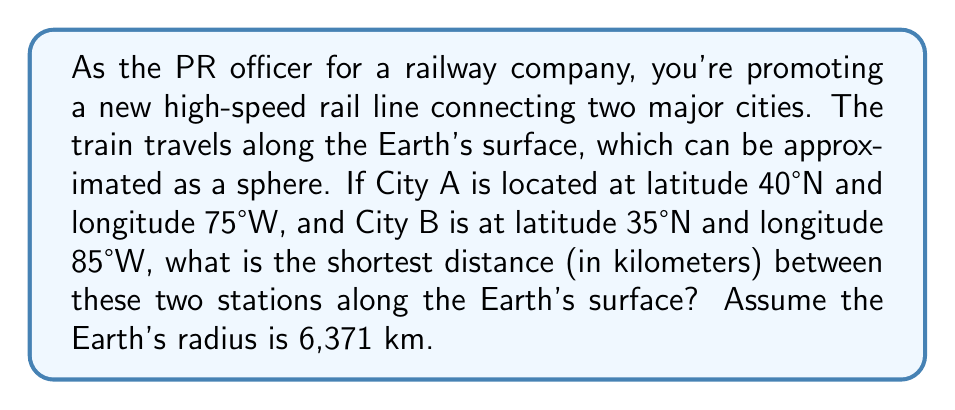Can you answer this question? To solve this problem, we'll use the Haversine formula to calculate the great-circle distance between two points on a sphere. This represents the geodesic distance between the two stations.

Step 1: Convert latitudes and longitudes to radians.
$$\begin{align*}
\phi_1 &= 40° \cdot \frac{\pi}{180} \approx 0.6981 \text{ rad} \\
\lambda_1 &= -75° \cdot \frac{\pi}{180} \approx -1.3090 \text{ rad} \\
\phi_2 &= 35° \cdot \frac{\pi}{180} \approx 0.6109 \text{ rad} \\
\lambda_2 &= -85° \cdot \frac{\pi}{180} \approx -1.4835 \text{ rad}
\end{align*}$$

Step 2: Calculate the differences in latitude and longitude.
$$\begin{align*}
\Delta\phi &= \phi_2 - \phi_1 \approx -0.0872 \text{ rad} \\
\Delta\lambda &= \lambda_2 - \lambda_1 \approx -0.1745 \text{ rad}
\end{align*}$$

Step 3: Apply the Haversine formula.
$$a = \sin^2(\frac{\Delta\phi}{2}) + \cos(\phi_1) \cos(\phi_2) \sin^2(\frac{\Delta\lambda}{2})$$

$$\begin{align*}
a &= \sin^2(-0.0436) + \cos(0.6981) \cos(0.6109) \sin^2(-0.0873) \\
&\approx 0.0019 + 0.7660 \cdot 0.8193 \cdot 0.0076 \\
&\approx 0.0019 + 0.0048 \\
&\approx 0.0067
\end{align*}$$

Step 4: Calculate the central angle.
$$c = 2 \arctan2(\sqrt{a}, \sqrt{1-a}) \approx 0.1635 \text{ rad}$$

Step 5: Calculate the great-circle distance.
$$d = R \cdot c$$
Where $R$ is the Earth's radius (6,371 km).

$$d = 6371 \cdot 0.1635 \approx 1041.66 \text{ km}$$

Therefore, the shortest distance between the two stations along the Earth's surface is approximately 1041.66 km.
Answer: 1041.66 km 